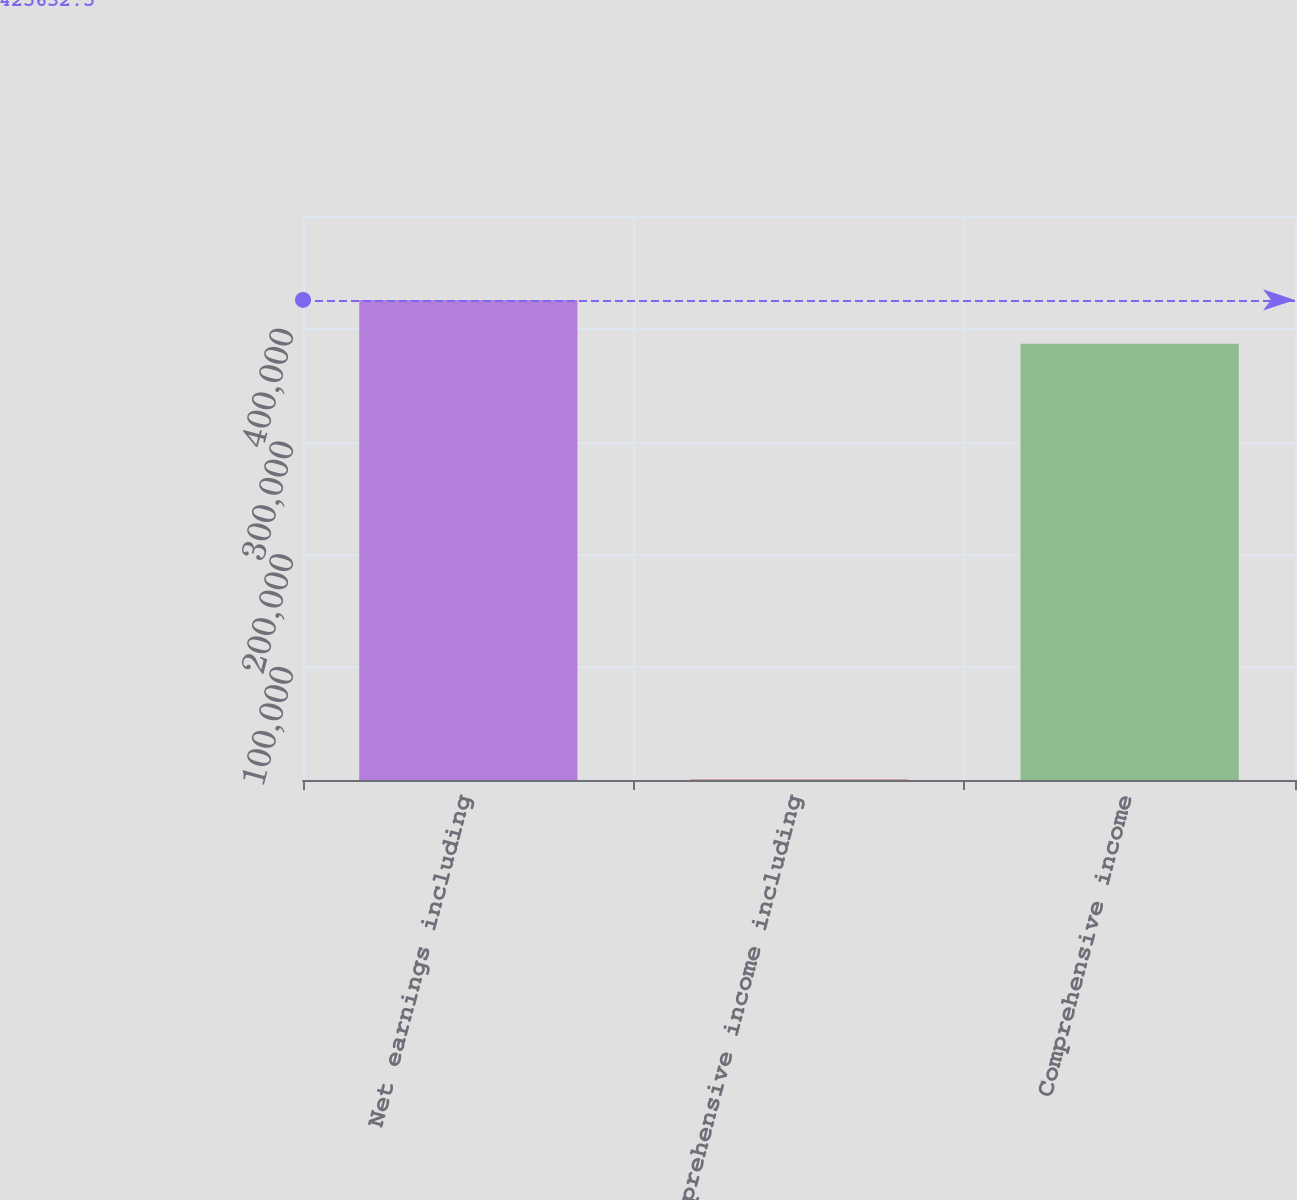Convert chart. <chart><loc_0><loc_0><loc_500><loc_500><bar_chart><fcel>Net earnings including<fcel>Comprehensive income including<fcel>Comprehensive income<nl><fcel>425632<fcel>476<fcel>386812<nl></chart> 